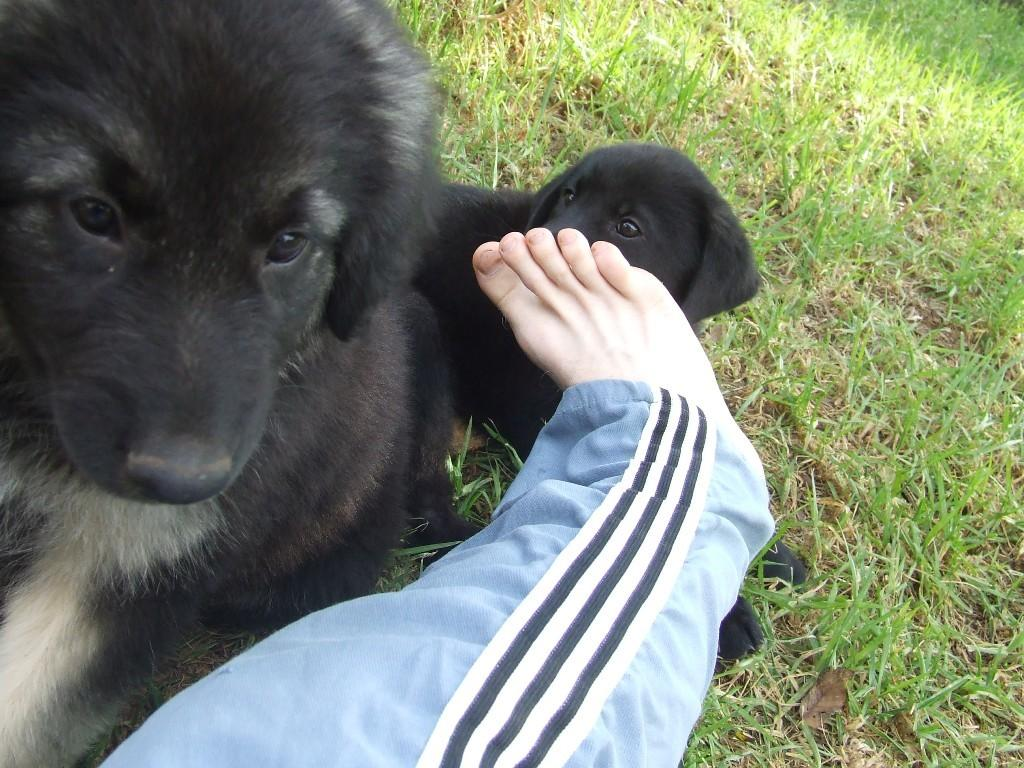What animals are present in the image? There are dogs in the image. Where are the dogs located? The dogs are on the grass. Can you describe the interaction between the dogs and a person? There is a person's leg on one of the dogs. What type of behavior is the yam exhibiting in the image? There is no yam present in the image, so it cannot exhibit any behavior. 